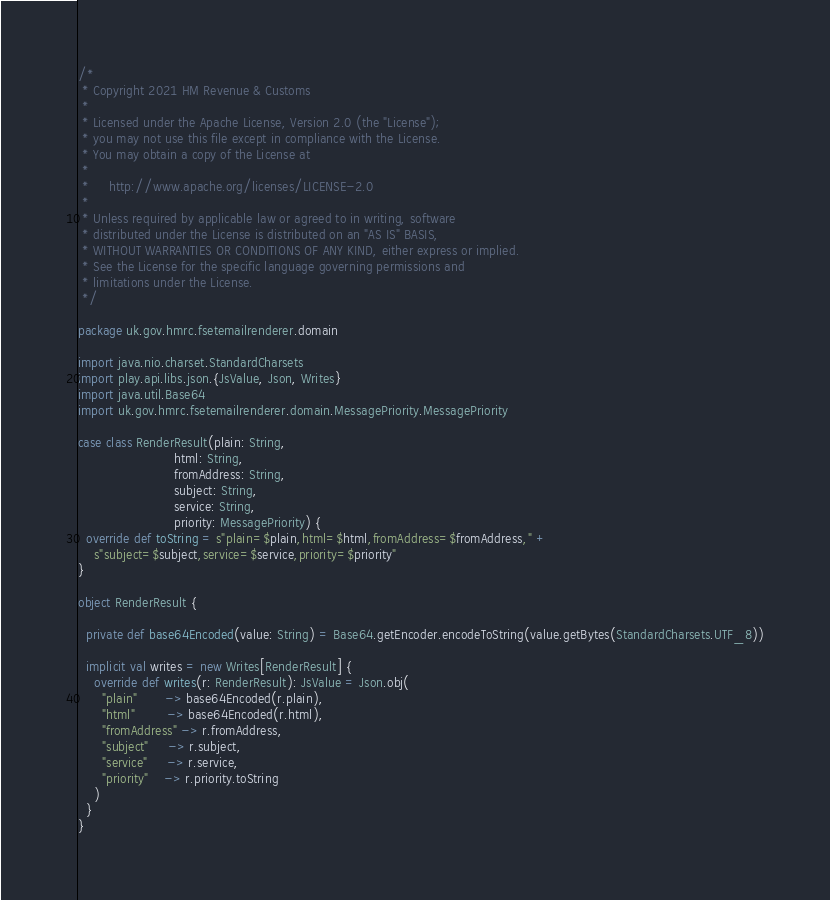<code> <loc_0><loc_0><loc_500><loc_500><_Scala_>/*
 * Copyright 2021 HM Revenue & Customs
 *
 * Licensed under the Apache License, Version 2.0 (the "License");
 * you may not use this file except in compliance with the License.
 * You may obtain a copy of the License at
 *
 *     http://www.apache.org/licenses/LICENSE-2.0
 *
 * Unless required by applicable law or agreed to in writing, software
 * distributed under the License is distributed on an "AS IS" BASIS,
 * WITHOUT WARRANTIES OR CONDITIONS OF ANY KIND, either express or implied.
 * See the License for the specific language governing permissions and
 * limitations under the License.
 */

package uk.gov.hmrc.fsetemailrenderer.domain

import java.nio.charset.StandardCharsets
import play.api.libs.json.{JsValue, Json, Writes}
import java.util.Base64
import uk.gov.hmrc.fsetemailrenderer.domain.MessagePriority.MessagePriority

case class RenderResult(plain: String,
                        html: String,
                        fromAddress: String,
                        subject: String,
                        service: String,
                        priority: MessagePriority) {
  override def toString = s"plain=$plain,html=$html,fromAddress=$fromAddress," +
    s"subject=$subject,service=$service,priority=$priority"
}

object RenderResult {

  private def base64Encoded(value: String) = Base64.getEncoder.encodeToString(value.getBytes(StandardCharsets.UTF_8))

  implicit val writes = new Writes[RenderResult] {
    override def writes(r: RenderResult): JsValue = Json.obj(
      "plain"       -> base64Encoded(r.plain),
      "html"        -> base64Encoded(r.html),
      "fromAddress" -> r.fromAddress,
      "subject"     -> r.subject,
      "service"     -> r.service,
      "priority"    -> r.priority.toString
    )
  }
}
</code> 